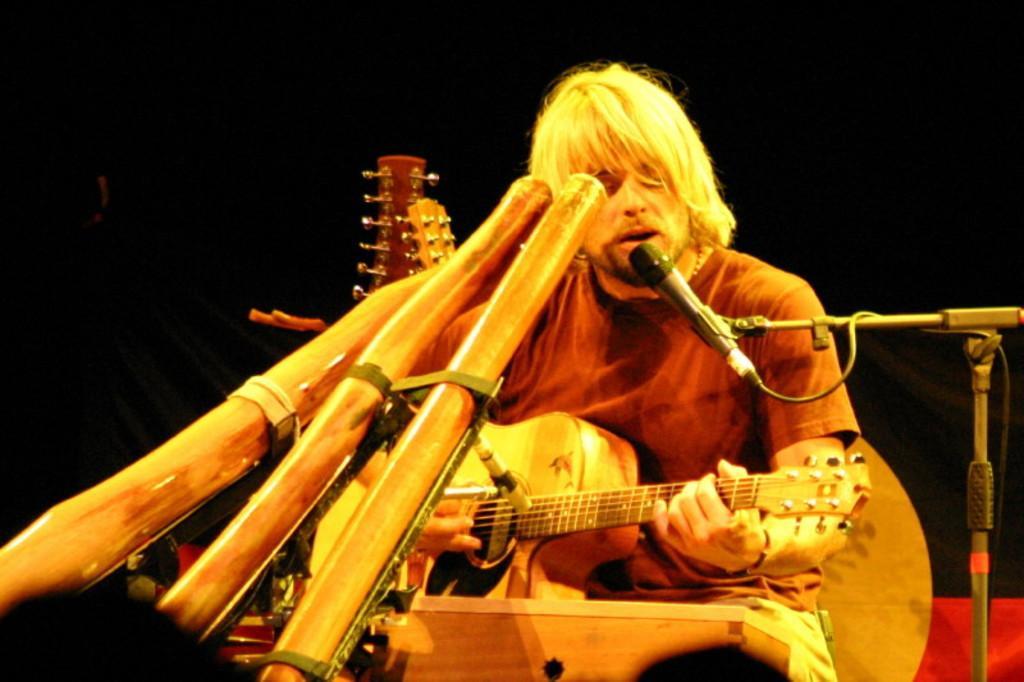Please provide a concise description of this image. There is a man playing guitar and singing in a microphone behind them there are so many other musical instruments. 